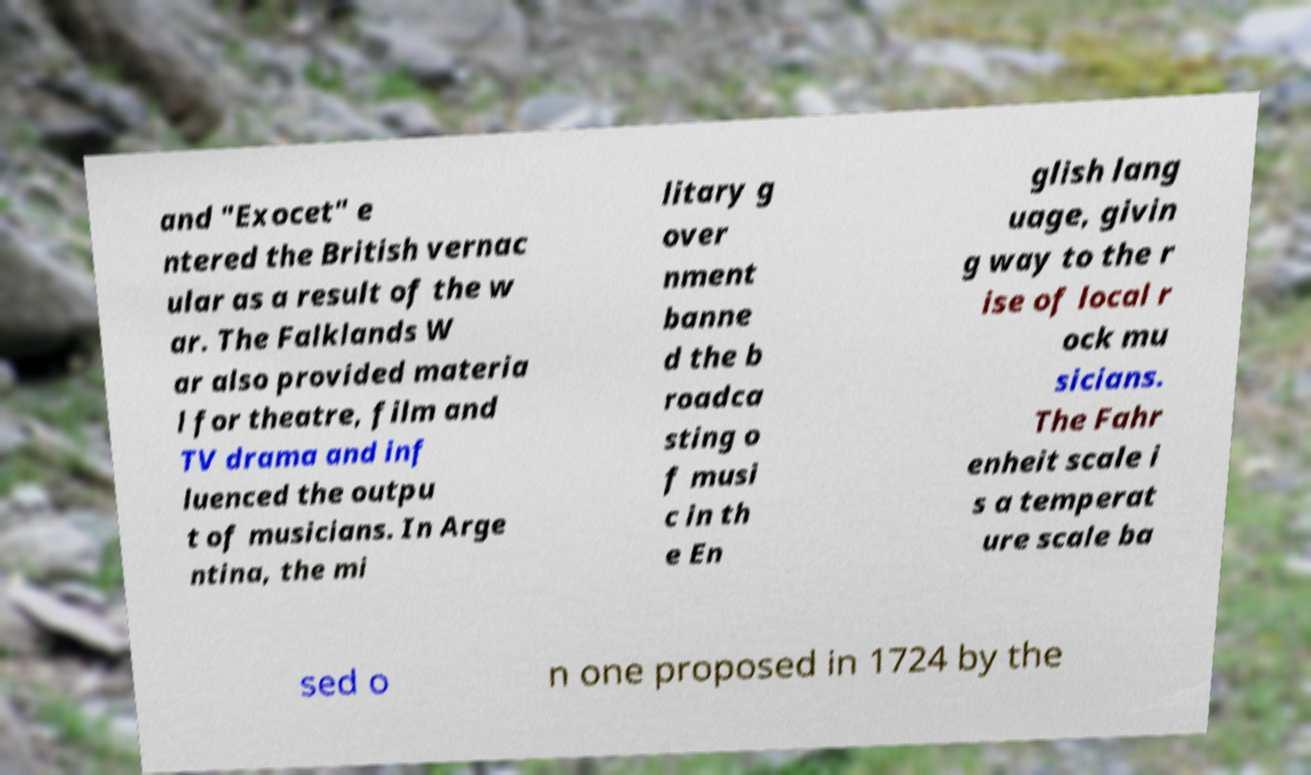Please read and relay the text visible in this image. What does it say? and "Exocet" e ntered the British vernac ular as a result of the w ar. The Falklands W ar also provided materia l for theatre, film and TV drama and inf luenced the outpu t of musicians. In Arge ntina, the mi litary g over nment banne d the b roadca sting o f musi c in th e En glish lang uage, givin g way to the r ise of local r ock mu sicians. The Fahr enheit scale i s a temperat ure scale ba sed o n one proposed in 1724 by the 